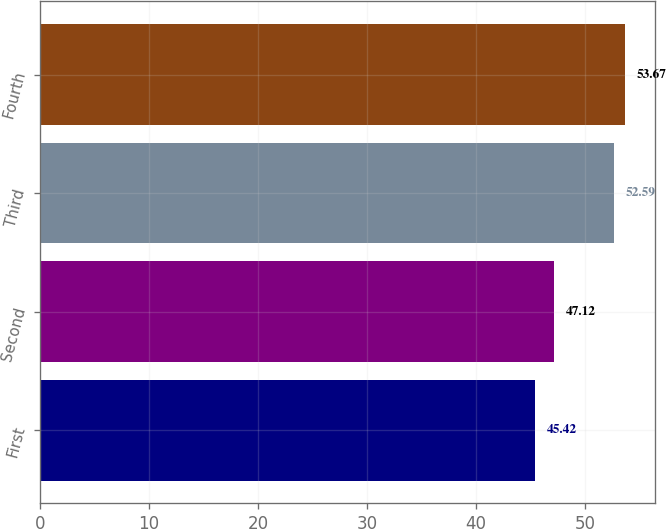Convert chart to OTSL. <chart><loc_0><loc_0><loc_500><loc_500><bar_chart><fcel>First<fcel>Second<fcel>Third<fcel>Fourth<nl><fcel>45.42<fcel>47.12<fcel>52.59<fcel>53.67<nl></chart> 